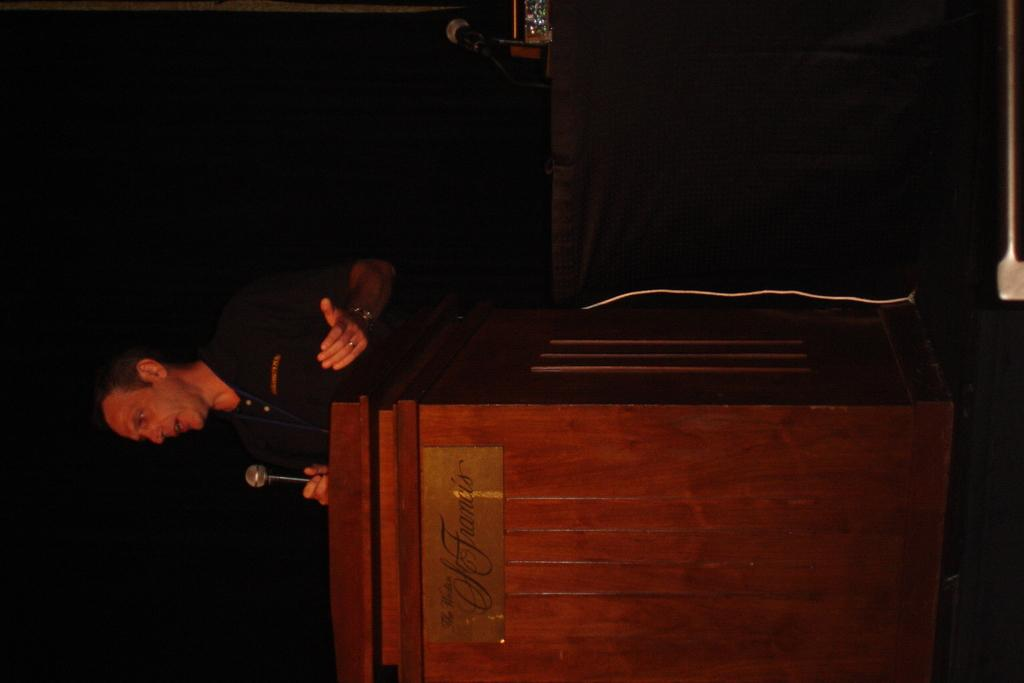Who is the main subject in the image? There is a man in the image. What is the man doing in the image? The man is standing near a podium and speaking with a microphone. What type of disease is the man spreading through the microphone in the image? There is no indication of a disease in the image, and the man is not spreading anything through the microphone. 